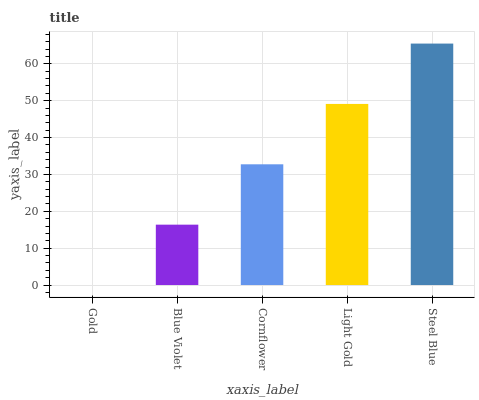Is Gold the minimum?
Answer yes or no. Yes. Is Steel Blue the maximum?
Answer yes or no. Yes. Is Blue Violet the minimum?
Answer yes or no. No. Is Blue Violet the maximum?
Answer yes or no. No. Is Blue Violet greater than Gold?
Answer yes or no. Yes. Is Gold less than Blue Violet?
Answer yes or no. Yes. Is Gold greater than Blue Violet?
Answer yes or no. No. Is Blue Violet less than Gold?
Answer yes or no. No. Is Cornflower the high median?
Answer yes or no. Yes. Is Cornflower the low median?
Answer yes or no. Yes. Is Blue Violet the high median?
Answer yes or no. No. Is Gold the low median?
Answer yes or no. No. 